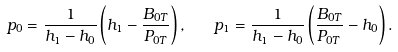Convert formula to latex. <formula><loc_0><loc_0><loc_500><loc_500>p _ { 0 } = \frac { 1 } { h _ { 1 } - h _ { 0 } } \left ( h _ { 1 } - \frac { B _ { 0 T } } { P _ { 0 T } } \right ) , \quad p _ { 1 } = \frac { 1 } { h _ { 1 } - h _ { 0 } } \left ( \frac { B _ { 0 T } } { P _ { 0 T } } - h _ { 0 } \right ) .</formula> 